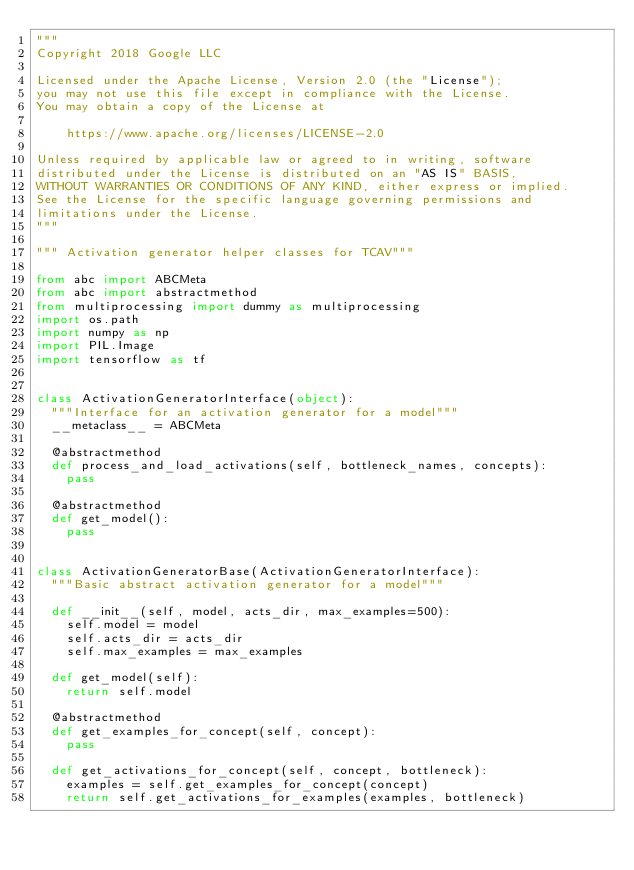<code> <loc_0><loc_0><loc_500><loc_500><_Python_>"""
Copyright 2018 Google LLC

Licensed under the Apache License, Version 2.0 (the "License");
you may not use this file except in compliance with the License.
You may obtain a copy of the License at

    https://www.apache.org/licenses/LICENSE-2.0

Unless required by applicable law or agreed to in writing, software
distributed under the License is distributed on an "AS IS" BASIS,
WITHOUT WARRANTIES OR CONDITIONS OF ANY KIND, either express or implied.
See the License for the specific language governing permissions and
limitations under the License.
"""

""" Activation generator helper classes for TCAV"""

from abc import ABCMeta
from abc import abstractmethod
from multiprocessing import dummy as multiprocessing
import os.path
import numpy as np
import PIL.Image
import tensorflow as tf


class ActivationGeneratorInterface(object):
  """Interface for an activation generator for a model"""
  __metaclass__ = ABCMeta

  @abstractmethod
  def process_and_load_activations(self, bottleneck_names, concepts):
    pass

  @abstractmethod
  def get_model():
    pass


class ActivationGeneratorBase(ActivationGeneratorInterface):
  """Basic abstract activation generator for a model"""

  def __init__(self, model, acts_dir, max_examples=500):
    self.model = model
    self.acts_dir = acts_dir
    self.max_examples = max_examples

  def get_model(self):
    return self.model

  @abstractmethod
  def get_examples_for_concept(self, concept):
    pass

  def get_activations_for_concept(self, concept, bottleneck):
    examples = self.get_examples_for_concept(concept)
    return self.get_activations_for_examples(examples, bottleneck)
</code> 